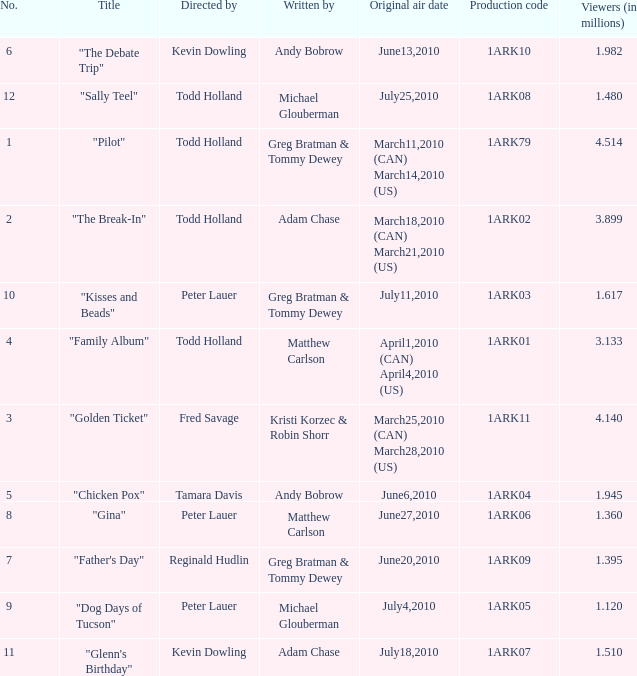What is the original air date for production code 1ark79? March11,2010 (CAN) March14,2010 (US). 